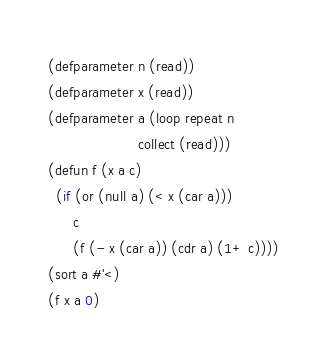Convert code to text. <code><loc_0><loc_0><loc_500><loc_500><_Lisp_>(defparameter n (read))
(defparameter x (read))
(defparameter a (loop repeat n
                      collect (read)))
(defun f (x a c)
  (if (or (null a) (< x (car a)))
      c
      (f (- x (car a)) (cdr a) (1+ c))))
(sort a #'<)
(f x a 0)</code> 